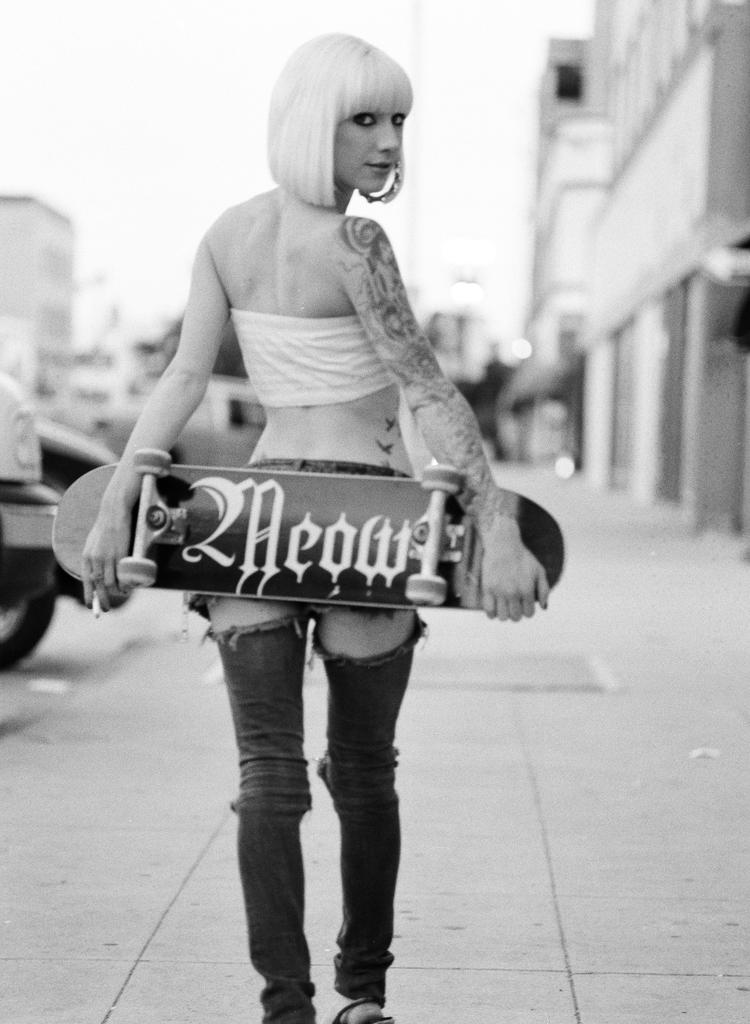What is the person in the image doing? The person is standing in the image and holding a skateboard. What can be seen in the background of the image? There are buildings in the background of the image. What is the color scheme of the image? The image is in black and white. How many lizards are crawling on the person's throat in the image? There are no lizards present in the image, and the person's throat is not visible. What type of art is displayed on the buildings in the background? The image is in black and white, and no specific art is visible on the buildings in the background. 